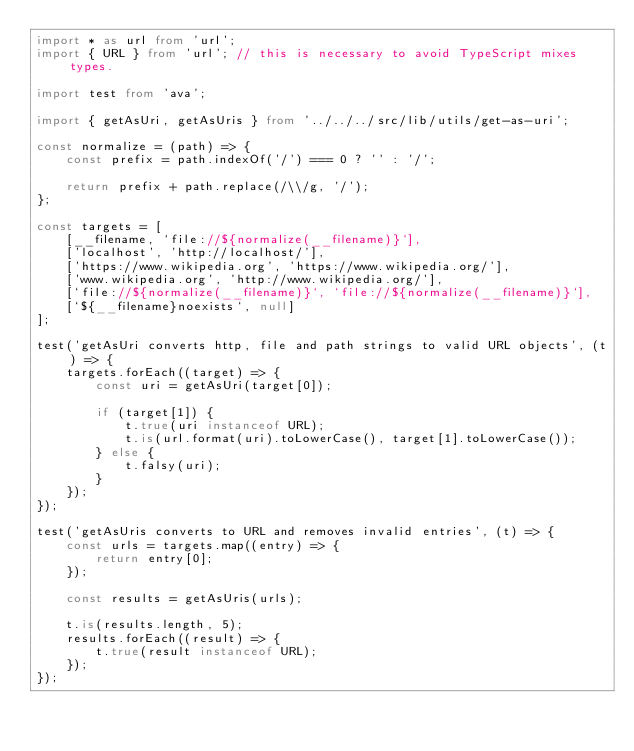Convert code to text. <code><loc_0><loc_0><loc_500><loc_500><_TypeScript_>import * as url from 'url';
import { URL } from 'url'; // this is necessary to avoid TypeScript mixes types.

import test from 'ava';

import { getAsUri, getAsUris } from '../../../src/lib/utils/get-as-uri';

const normalize = (path) => {
    const prefix = path.indexOf('/') === 0 ? '' : '/';

    return prefix + path.replace(/\\/g, '/');
};

const targets = [
    [__filename, `file://${normalize(__filename)}`],
    ['localhost', 'http://localhost/'],
    ['https://www.wikipedia.org', 'https://www.wikipedia.org/'],
    ['www.wikipedia.org', 'http://www.wikipedia.org/'],
    [`file://${normalize(__filename)}`, `file://${normalize(__filename)}`],
    [`${__filename}noexists`, null]
];

test('getAsUri converts http, file and path strings to valid URL objects', (t) => {
    targets.forEach((target) => {
        const uri = getAsUri(target[0]);

        if (target[1]) {
            t.true(uri instanceof URL);
            t.is(url.format(uri).toLowerCase(), target[1].toLowerCase());
        } else {
            t.falsy(uri);
        }
    });
});

test('getAsUris converts to URL and removes invalid entries', (t) => {
    const urls = targets.map((entry) => {
        return entry[0];
    });

    const results = getAsUris(urls);

    t.is(results.length, 5);
    results.forEach((result) => {
        t.true(result instanceof URL);
    });
});
</code> 